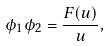Convert formula to latex. <formula><loc_0><loc_0><loc_500><loc_500>\phi _ { 1 } \phi _ { 2 } = \frac { F ( u ) } { u } ,</formula> 